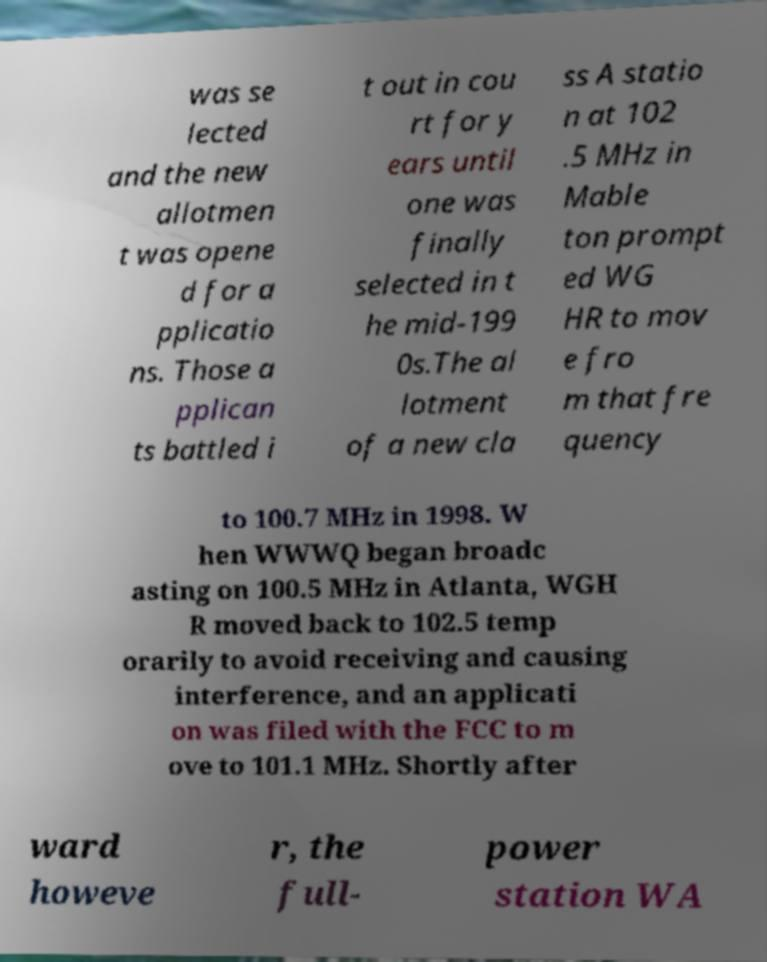Could you assist in decoding the text presented in this image and type it out clearly? was se lected and the new allotmen t was opene d for a pplicatio ns. Those a pplican ts battled i t out in cou rt for y ears until one was finally selected in t he mid-199 0s.The al lotment of a new cla ss A statio n at 102 .5 MHz in Mable ton prompt ed WG HR to mov e fro m that fre quency to 100.7 MHz in 1998. W hen WWWQ began broadc asting on 100.5 MHz in Atlanta, WGH R moved back to 102.5 temp orarily to avoid receiving and causing interference, and an applicati on was filed with the FCC to m ove to 101.1 MHz. Shortly after ward howeve r, the full- power station WA 